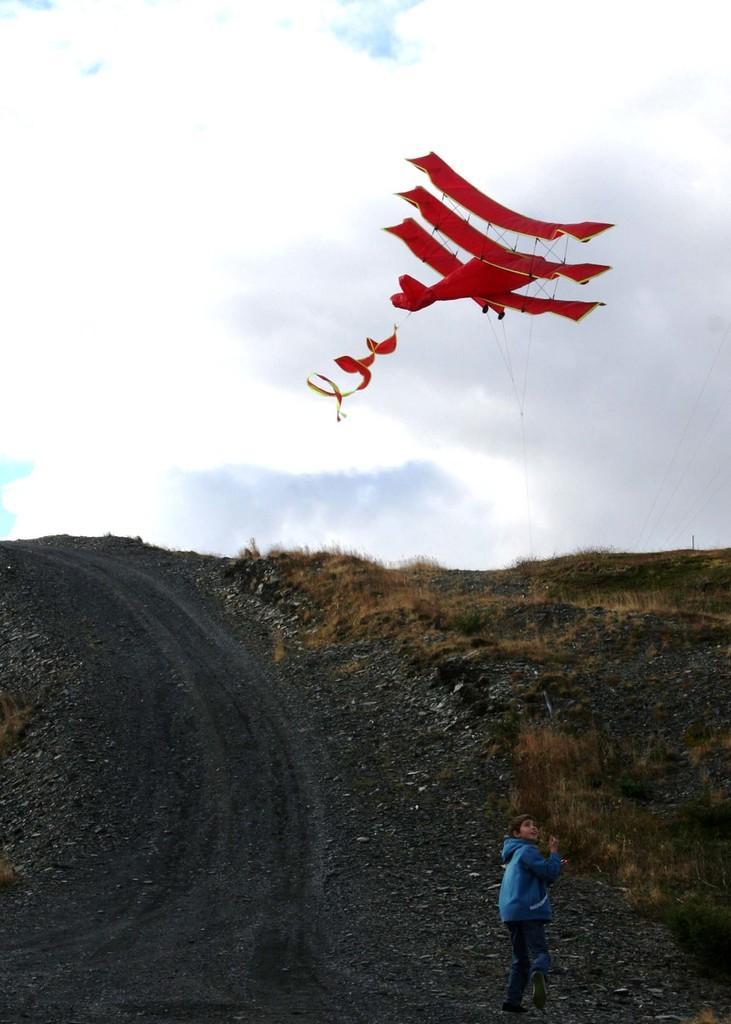Describe this image in one or two sentences. In this image we can see a boy flying a kite with a thread. We can also see some grass, stones, a pathway and the sky which looks cloudy. 